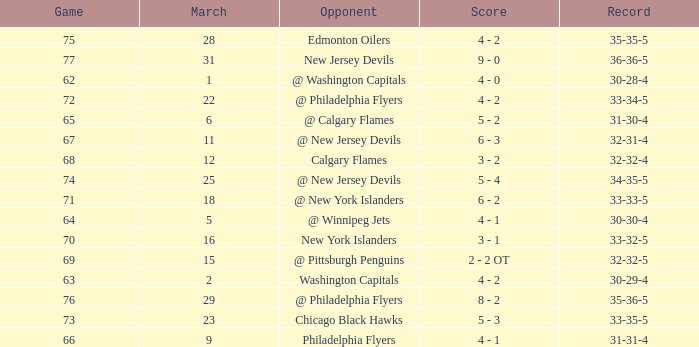How many games ended in a record of 30-28-4, with a March more than 1? 0.0. 